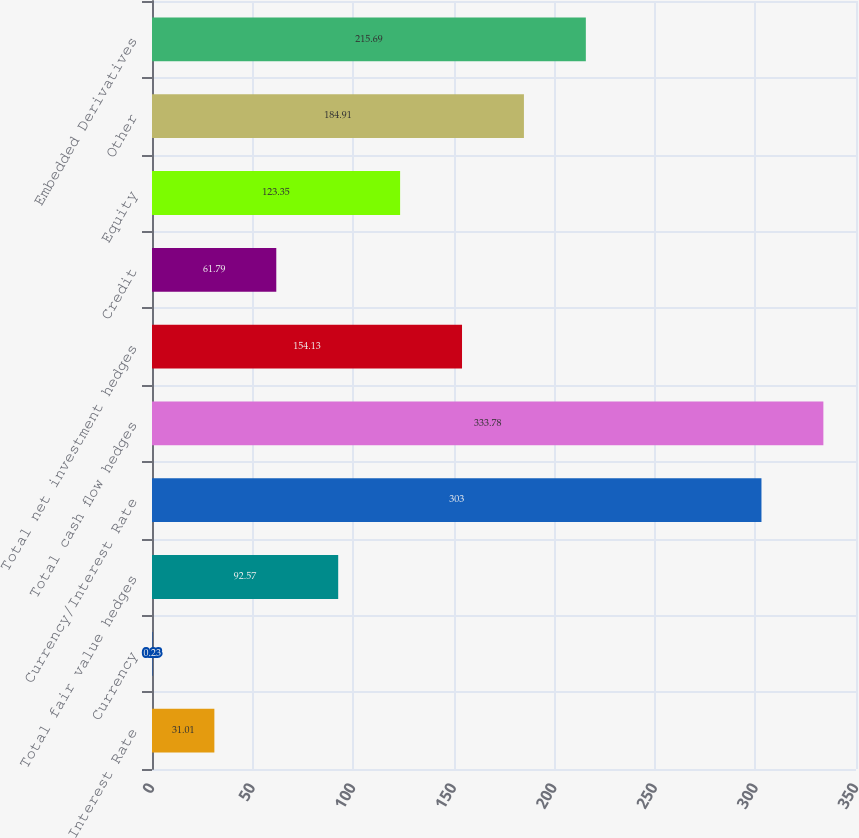Convert chart. <chart><loc_0><loc_0><loc_500><loc_500><bar_chart><fcel>Interest Rate<fcel>Currency<fcel>Total fair value hedges<fcel>Currency/Interest Rate<fcel>Total cash flow hedges<fcel>Total net investment hedges<fcel>Credit<fcel>Equity<fcel>Other<fcel>Embedded Derivatives<nl><fcel>31.01<fcel>0.23<fcel>92.57<fcel>303<fcel>333.78<fcel>154.13<fcel>61.79<fcel>123.35<fcel>184.91<fcel>215.69<nl></chart> 